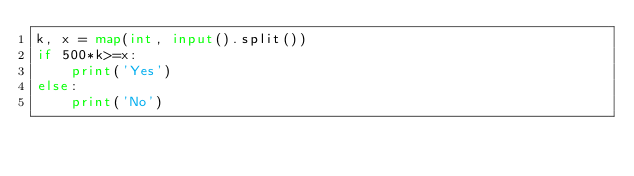Convert code to text. <code><loc_0><loc_0><loc_500><loc_500><_Python_>k, x = map(int, input().split())
if 500*k>=x:
    print('Yes')
else:
    print('No')</code> 